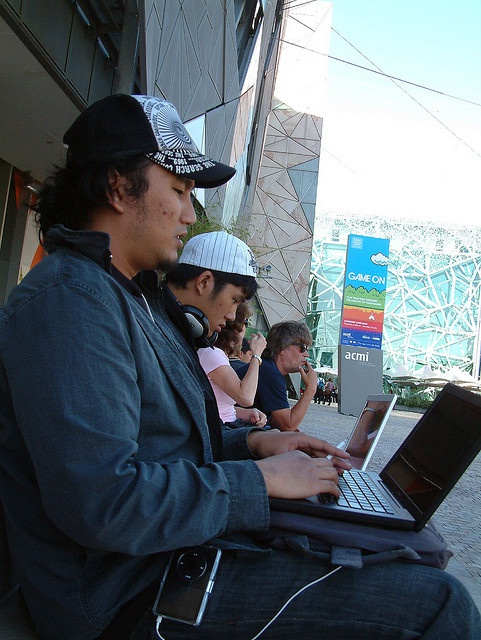Describe the objects in this image and their specific colors. I can see people in black, navy, blue, and gray tones, laptop in black, gray, and lightblue tones, people in black, lightblue, gray, and brown tones, people in black, gray, and maroon tones, and people in black, darkgray, gray, and brown tones in this image. 